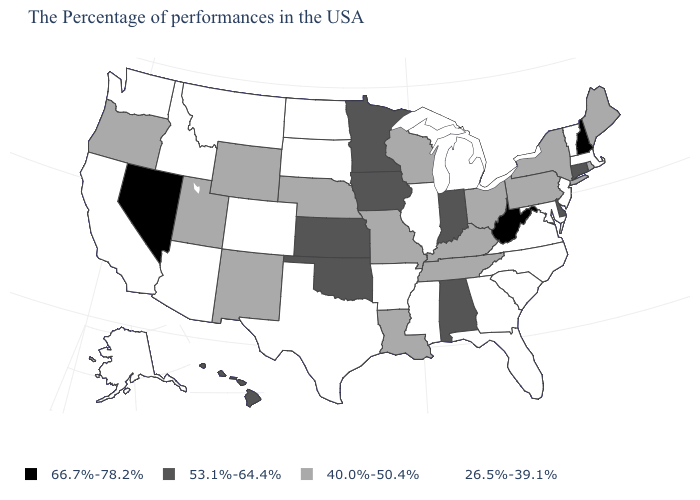Name the states that have a value in the range 40.0%-50.4%?
Concise answer only. Maine, Rhode Island, New York, Pennsylvania, Ohio, Kentucky, Tennessee, Wisconsin, Louisiana, Missouri, Nebraska, Wyoming, New Mexico, Utah, Oregon. What is the value of Minnesota?
Keep it brief. 53.1%-64.4%. What is the value of New York?
Short answer required. 40.0%-50.4%. What is the value of Tennessee?
Short answer required. 40.0%-50.4%. What is the value of New York?
Short answer required. 40.0%-50.4%. Among the states that border New Mexico , which have the lowest value?
Give a very brief answer. Texas, Colorado, Arizona. Which states hav the highest value in the Northeast?
Write a very short answer. New Hampshire. Which states have the lowest value in the MidWest?
Concise answer only. Michigan, Illinois, South Dakota, North Dakota. What is the value of Indiana?
Short answer required. 53.1%-64.4%. What is the highest value in the USA?
Keep it brief. 66.7%-78.2%. Does Nebraska have the lowest value in the USA?
Short answer required. No. Does the map have missing data?
Be succinct. No. What is the highest value in the USA?
Answer briefly. 66.7%-78.2%. What is the value of Mississippi?
Concise answer only. 26.5%-39.1%. Which states have the lowest value in the MidWest?
Short answer required. Michigan, Illinois, South Dakota, North Dakota. 